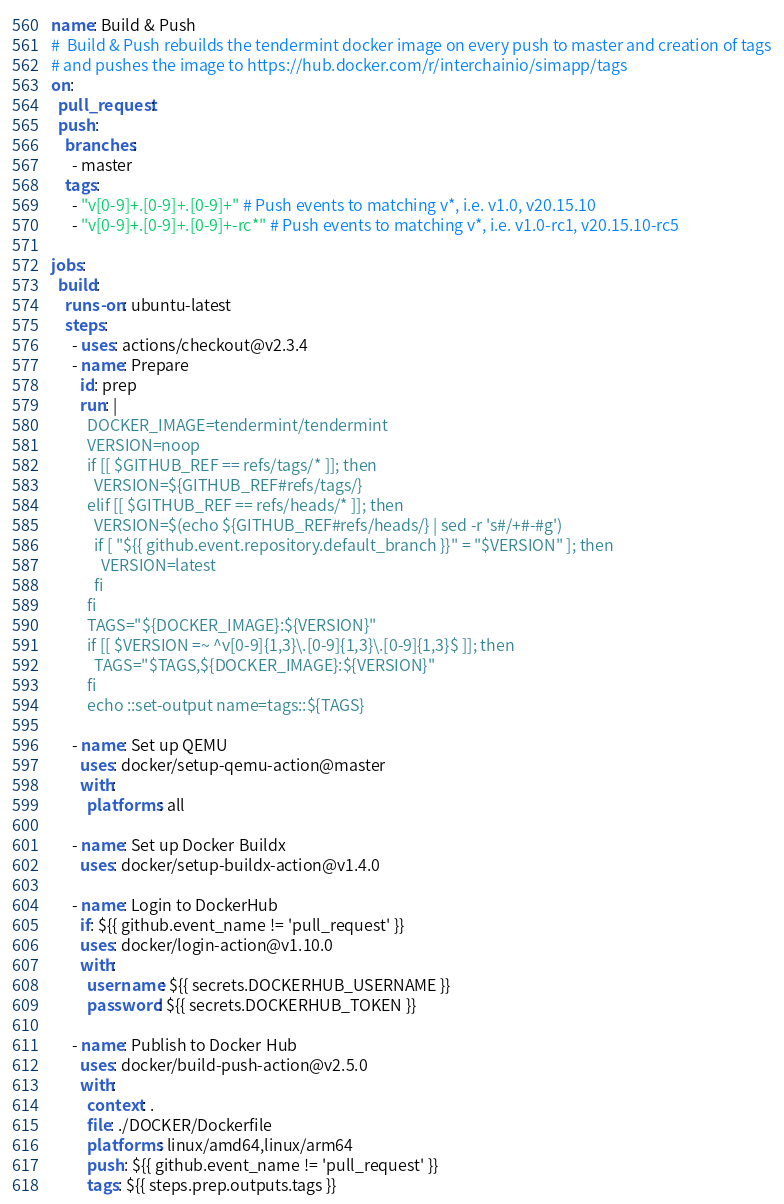<code> <loc_0><loc_0><loc_500><loc_500><_YAML_>name: Build & Push
#  Build & Push rebuilds the tendermint docker image on every push to master and creation of tags
# and pushes the image to https://hub.docker.com/r/interchainio/simapp/tags
on:
  pull_request:
  push:
    branches:
      - master
    tags:
      - "v[0-9]+.[0-9]+.[0-9]+" # Push events to matching v*, i.e. v1.0, v20.15.10
      - "v[0-9]+.[0-9]+.[0-9]+-rc*" # Push events to matching v*, i.e. v1.0-rc1, v20.15.10-rc5

jobs:
  build:
    runs-on: ubuntu-latest
    steps:
      - uses: actions/checkout@v2.3.4
      - name: Prepare
        id: prep
        run: |
          DOCKER_IMAGE=tendermint/tendermint
          VERSION=noop
          if [[ $GITHUB_REF == refs/tags/* ]]; then
            VERSION=${GITHUB_REF#refs/tags/}
          elif [[ $GITHUB_REF == refs/heads/* ]]; then
            VERSION=$(echo ${GITHUB_REF#refs/heads/} | sed -r 's#/+#-#g')
            if [ "${{ github.event.repository.default_branch }}" = "$VERSION" ]; then
              VERSION=latest
            fi
          fi
          TAGS="${DOCKER_IMAGE}:${VERSION}"
          if [[ $VERSION =~ ^v[0-9]{1,3}\.[0-9]{1,3}\.[0-9]{1,3}$ ]]; then
            TAGS="$TAGS,${DOCKER_IMAGE}:${VERSION}"
          fi
          echo ::set-output name=tags::${TAGS}

      - name: Set up QEMU
        uses: docker/setup-qemu-action@master
        with:
          platforms: all

      - name: Set up Docker Buildx
        uses: docker/setup-buildx-action@v1.4.0

      - name: Login to DockerHub
        if: ${{ github.event_name != 'pull_request' }}
        uses: docker/login-action@v1.10.0
        with:
          username: ${{ secrets.DOCKERHUB_USERNAME }}
          password: ${{ secrets.DOCKERHUB_TOKEN }}

      - name: Publish to Docker Hub
        uses: docker/build-push-action@v2.5.0
        with:
          context: .
          file: ./DOCKER/Dockerfile
          platforms: linux/amd64,linux/arm64
          push: ${{ github.event_name != 'pull_request' }}
          tags: ${{ steps.prep.outputs.tags }}
</code> 